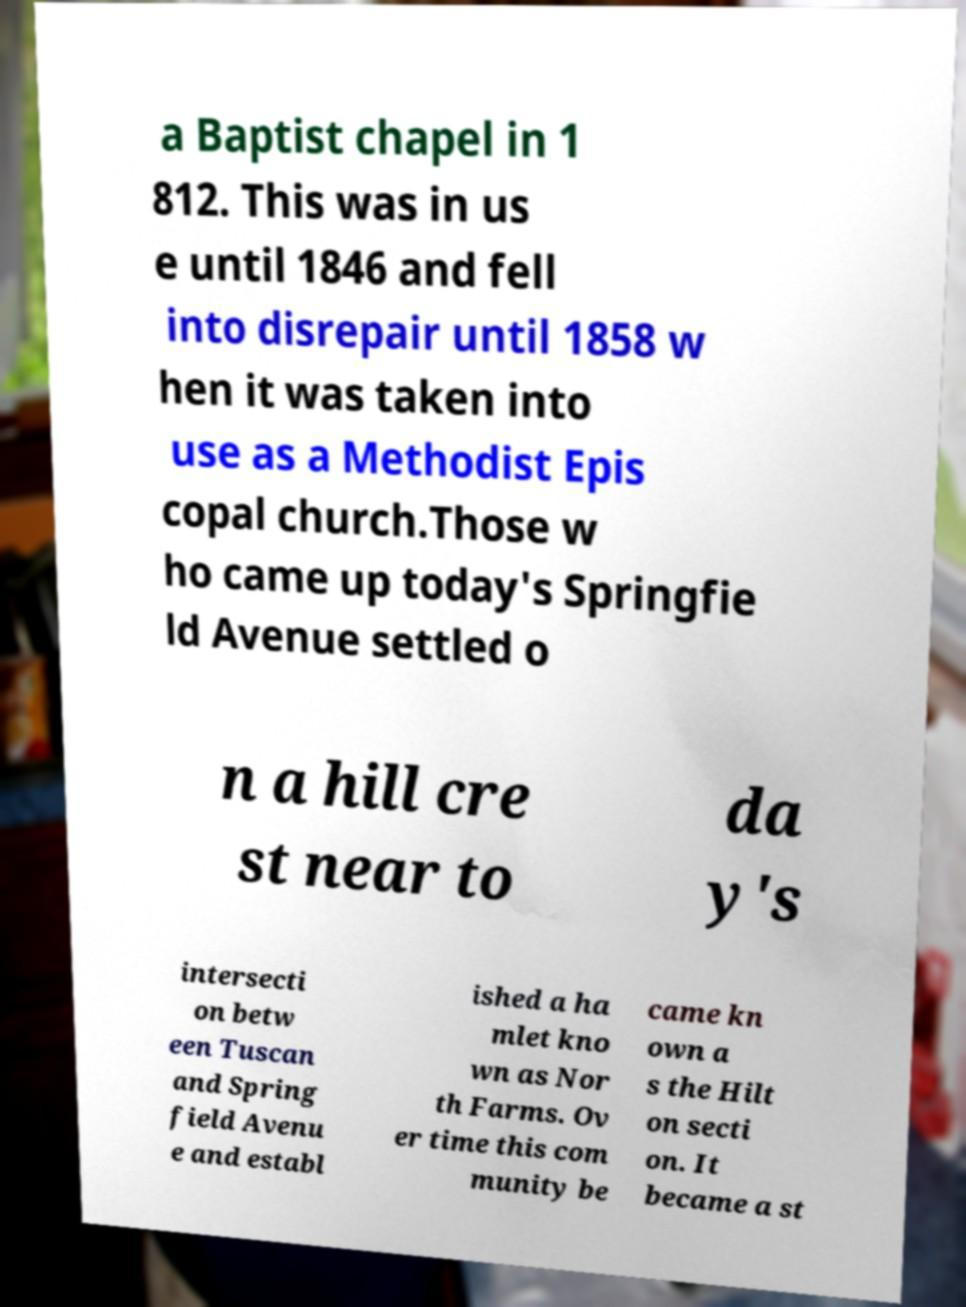Please read and relay the text visible in this image. What does it say? a Baptist chapel in 1 812. This was in us e until 1846 and fell into disrepair until 1858 w hen it was taken into use as a Methodist Epis copal church.Those w ho came up today's Springfie ld Avenue settled o n a hill cre st near to da y's intersecti on betw een Tuscan and Spring field Avenu e and establ ished a ha mlet kno wn as Nor th Farms. Ov er time this com munity be came kn own a s the Hilt on secti on. It became a st 